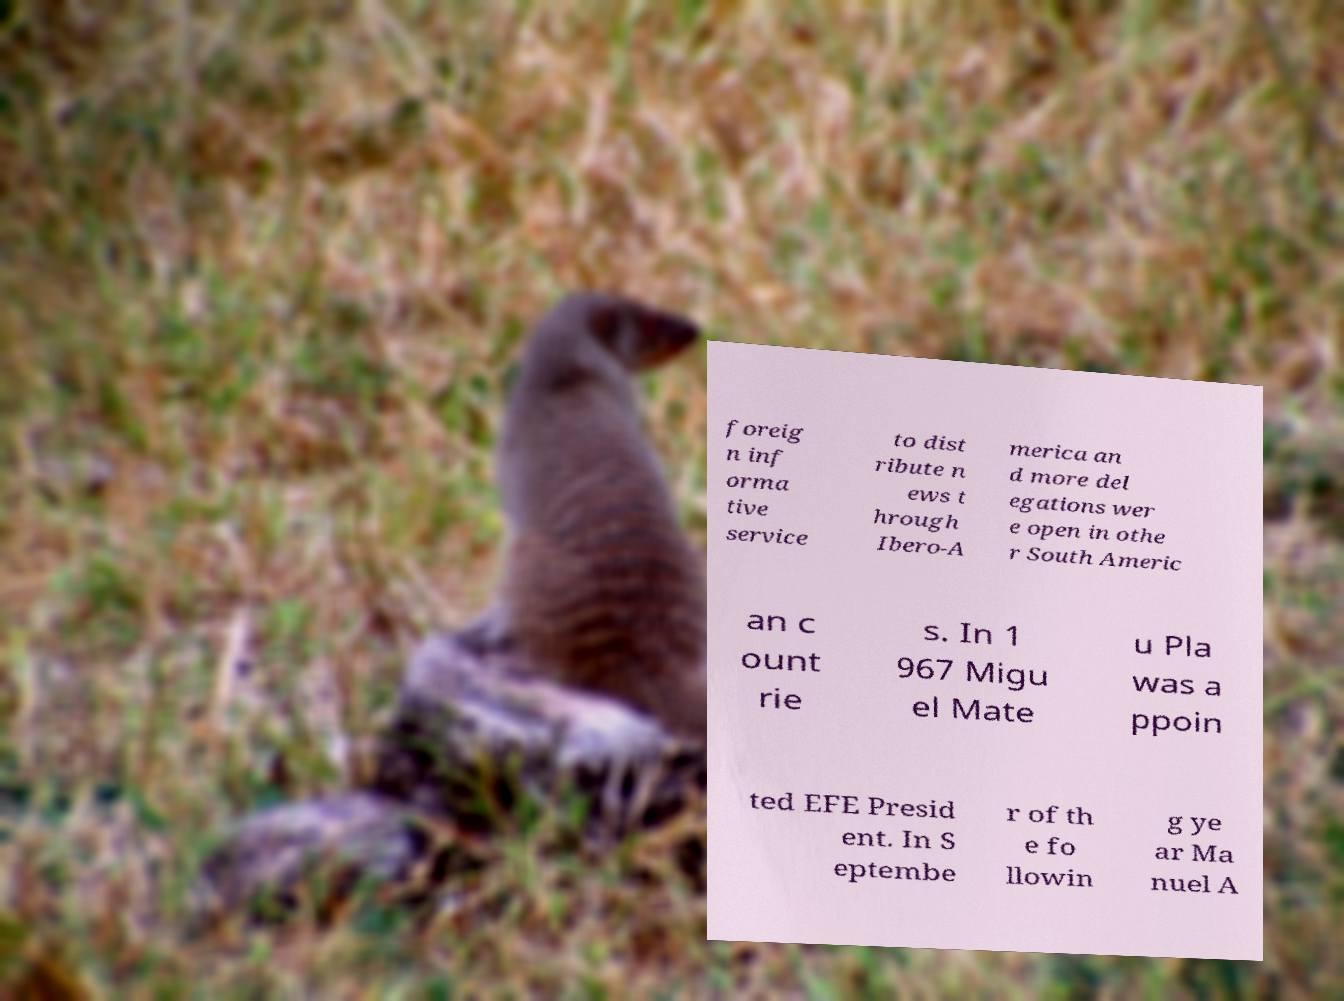Could you assist in decoding the text presented in this image and type it out clearly? foreig n inf orma tive service to dist ribute n ews t hrough Ibero-A merica an d more del egations wer e open in othe r South Americ an c ount rie s. In 1 967 Migu el Mate u Pla was a ppoin ted EFE Presid ent. In S eptembe r of th e fo llowin g ye ar Ma nuel A 